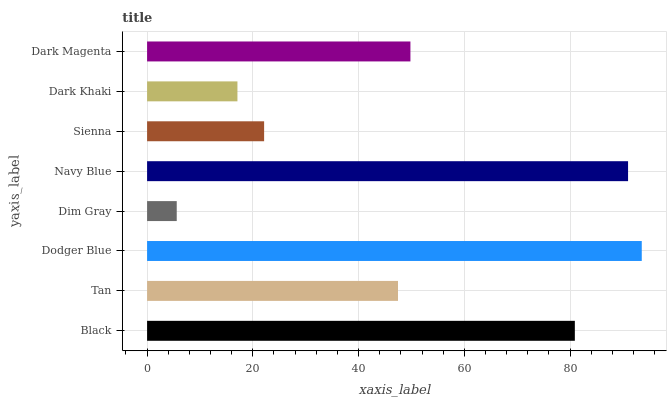Is Dim Gray the minimum?
Answer yes or no. Yes. Is Dodger Blue the maximum?
Answer yes or no. Yes. Is Tan the minimum?
Answer yes or no. No. Is Tan the maximum?
Answer yes or no. No. Is Black greater than Tan?
Answer yes or no. Yes. Is Tan less than Black?
Answer yes or no. Yes. Is Tan greater than Black?
Answer yes or no. No. Is Black less than Tan?
Answer yes or no. No. Is Dark Magenta the high median?
Answer yes or no. Yes. Is Tan the low median?
Answer yes or no. Yes. Is Navy Blue the high median?
Answer yes or no. No. Is Dark Magenta the low median?
Answer yes or no. No. 